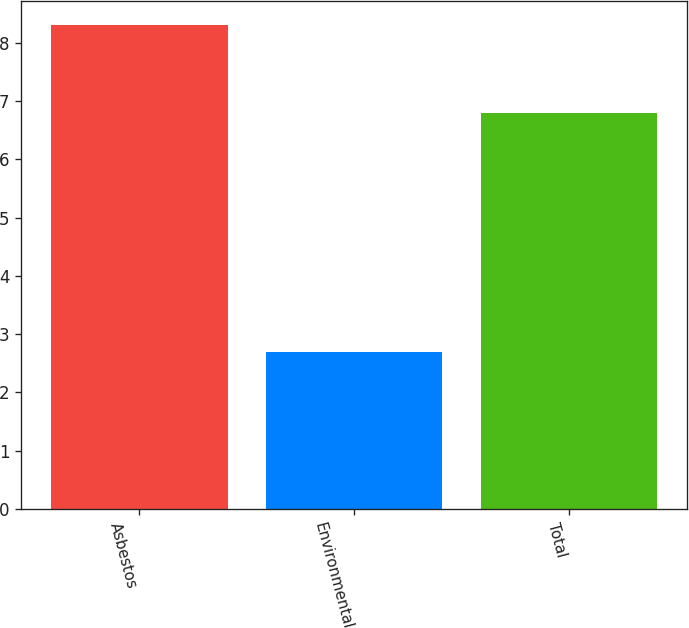<chart> <loc_0><loc_0><loc_500><loc_500><bar_chart><fcel>Asbestos<fcel>Environmental<fcel>Total<nl><fcel>8.3<fcel>2.7<fcel>6.8<nl></chart> 